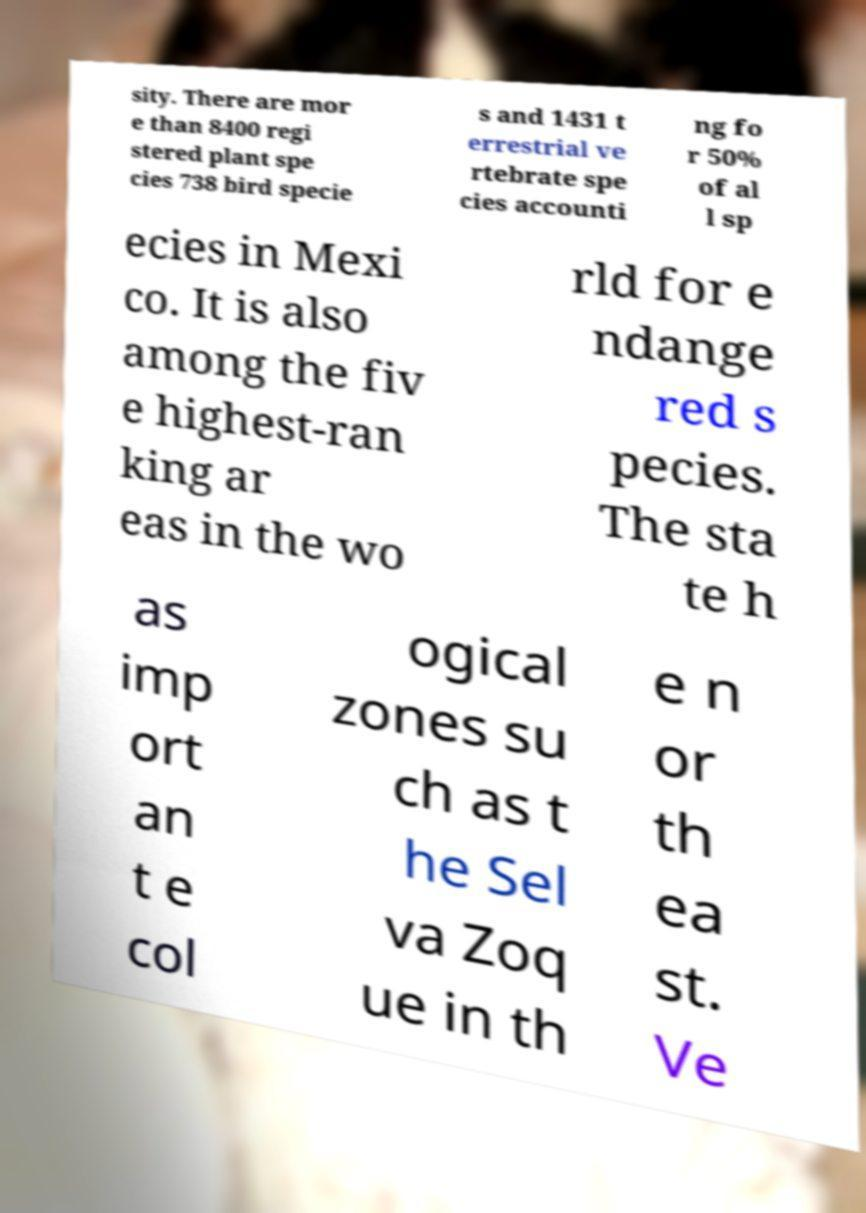What messages or text are displayed in this image? I need them in a readable, typed format. sity. There are mor e than 8400 regi stered plant spe cies 738 bird specie s and 1431 t errestrial ve rtebrate spe cies accounti ng fo r 50% of al l sp ecies in Mexi co. It is also among the fiv e highest-ran king ar eas in the wo rld for e ndange red s pecies. The sta te h as imp ort an t e col ogical zones su ch as t he Sel va Zoq ue in th e n or th ea st. Ve 